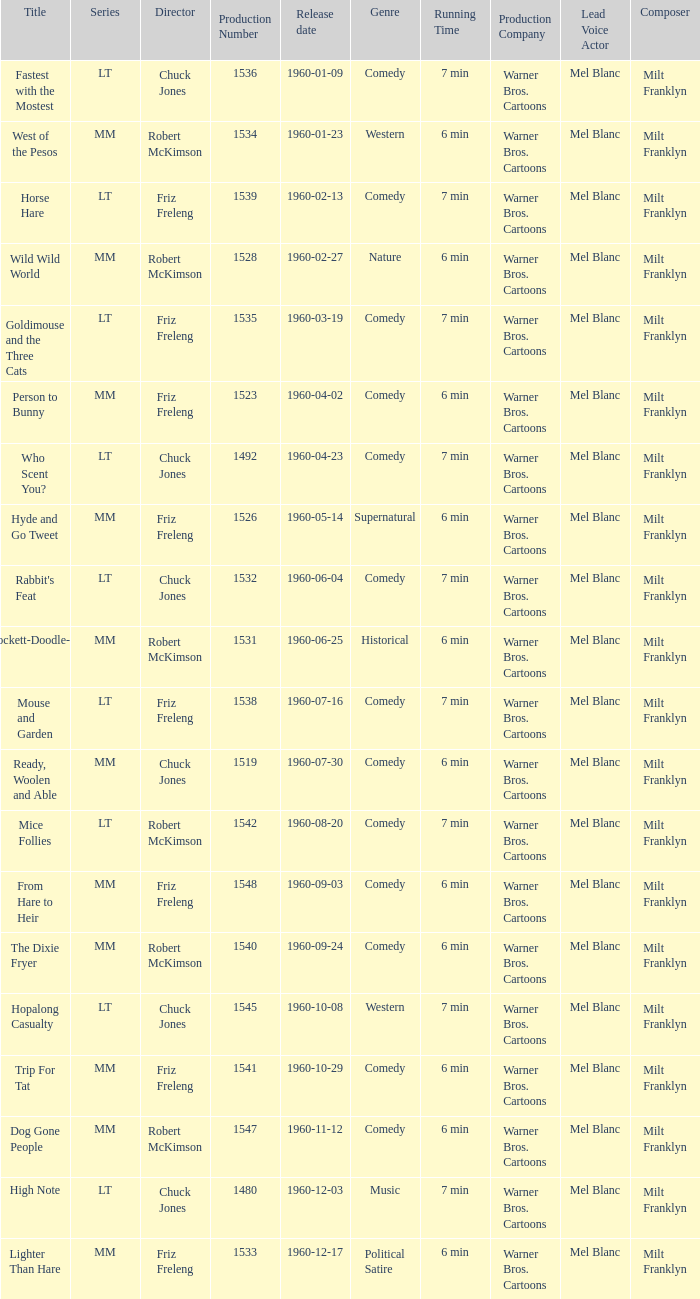What is the production number for the episode directed by Robert McKimson named Mice Follies? 1.0. 